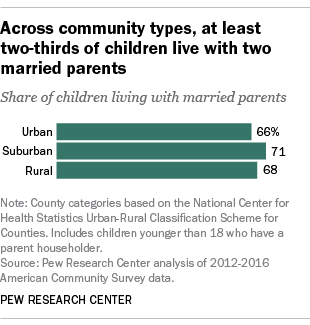Outline some significant characteristics in this image. The average value of the suburban and rural bars in the graph is approximately 69.5. The value of the largest bar in the graph is 71. 